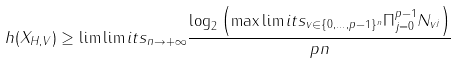Convert formula to latex. <formula><loc_0><loc_0><loc_500><loc_500>h ( X _ { H , V } ) \geq \lim \lim i t s _ { n \to + \infty } \frac { \log _ { 2 } \left ( \max \lim i t s _ { v \in \{ 0 , \dots , p - 1 \} ^ { n } } \Pi _ { j = 0 } ^ { p - 1 } N _ { v ^ { j } } \right ) } { p n }</formula> 